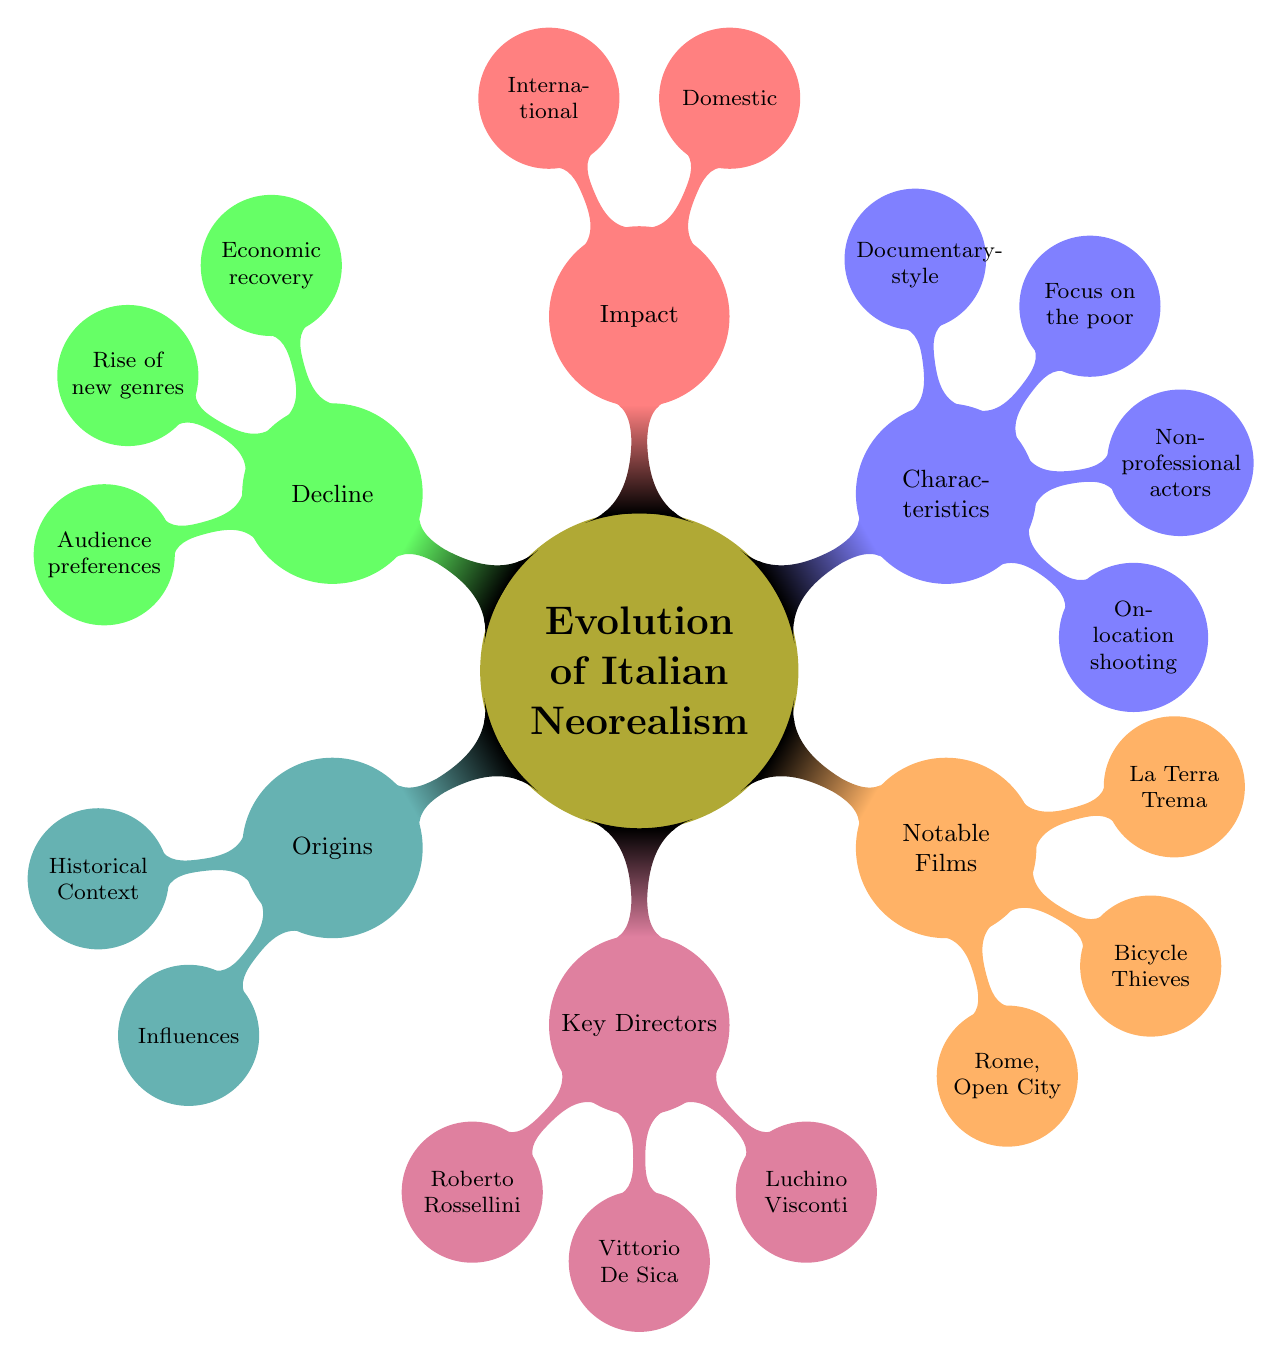What are the three key directors of Italian Neorealism? The diagram lists three key directors under the "Key Directors" node. They are Roberto Rossellini, Vittorio De Sica, and Luchino Visconti.
Answer: Roberto Rossellini, Vittorio De Sica, Luchino Visconti How many notable films are mentioned in the diagram? In the "Notable Films" section, the diagram lists three films: Rome, Open City, Bicycle Thieves, and La Terra Trema. Thus, there are three notable films mentioned.
Answer: 3 What is one characteristic of Italian Neorealism? Selecting any of the nodes under the "Characteristics" node, we can see that it includes on-location shooting, non-professional actors, focus on the poor and working class, or documentary-style visual aesthetic.
Answer: On-location shooting Which historical context contributed to the origins of Italian Neorealism? According to the "Historical Context" section under "Origins," the historical context includes Post-World War II Italy, which is a direct cause contributing to the emergence of Italian Neorealism.
Answer: Post-World War II Italy What type of film movement did Italian Neorealism influence internationally? The "Impact" section notes that Italian Neorealism influenced the French New Wave, which indicates its international impact on the film movement.
Answer: French New Wave What factors contributed to the decline of Italian Neorealism? The diagram provides three factors under the "Decline" node: economic recovery of Italy, rise of new genres, and shifts in audience preferences. These factors collectively elucidate why Italian Neorealism declined.
Answer: Economic recovery of Italy, rise of new genres, shifts in audience preferences How did Italian Neorealism affect new Italian directors? The "Domestic" section under "Impact" illustrates that it led to the formation of new Italian directors, which includes noted filmmakers like Federico Fellini.
Answer: Formation of new Italian directors What influences shaped Italian Neorealism? The diagram specifies the "Influences" node under "Origins," which includes French Poetic Realism, Marxist theories, and American cinema. These influences are critical in shaping Italian Neorealism.
Answer: French Poetic Realism, Marxist theories, American cinema 